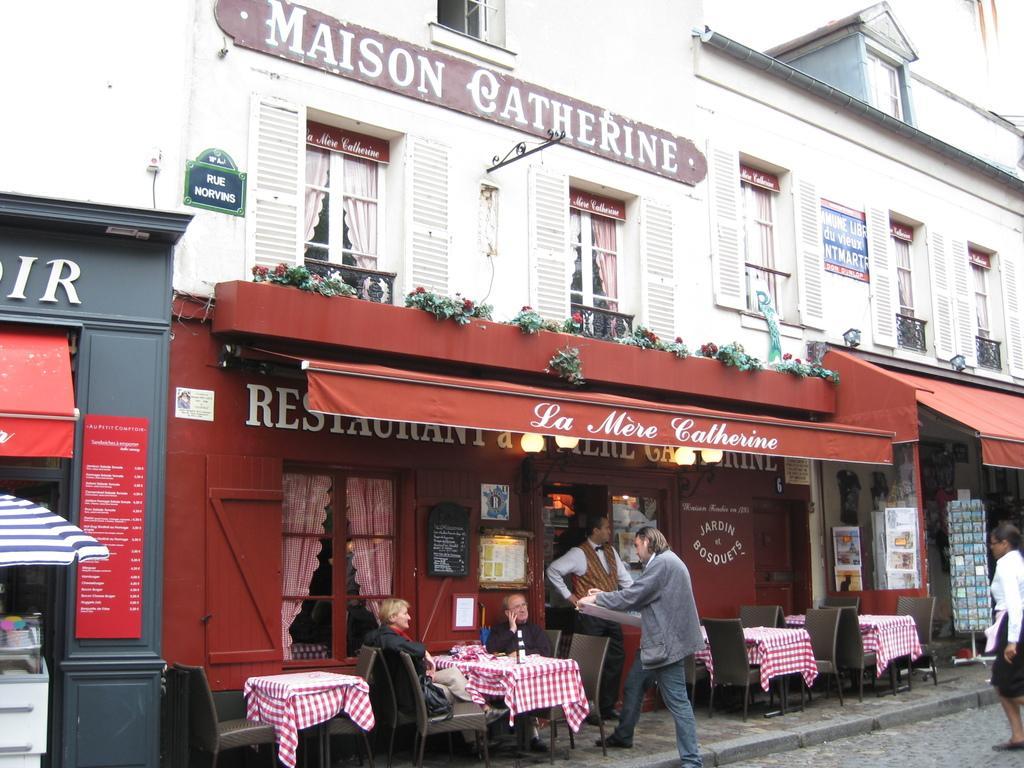Could you give a brief overview of what you see in this image? in this image there is a building , table , chair , bottle, hoarding , name board , persons , umbrella, plants. 